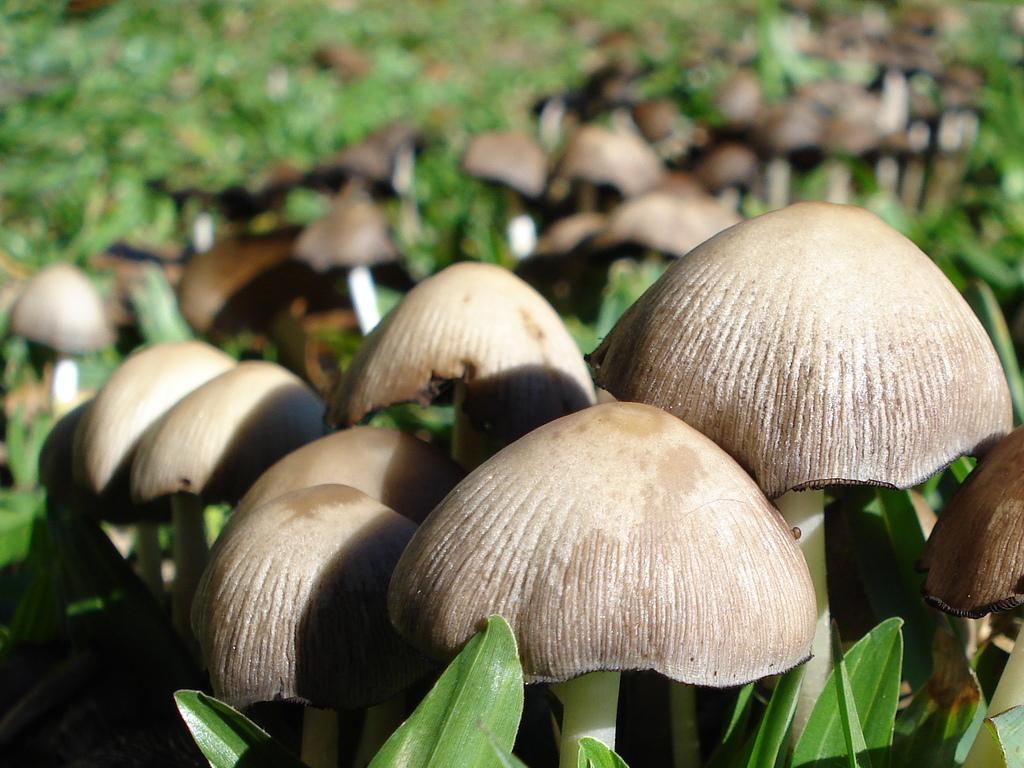How would you summarize this image in a sentence or two? In this image there are so many mushrooms in between the grass. 